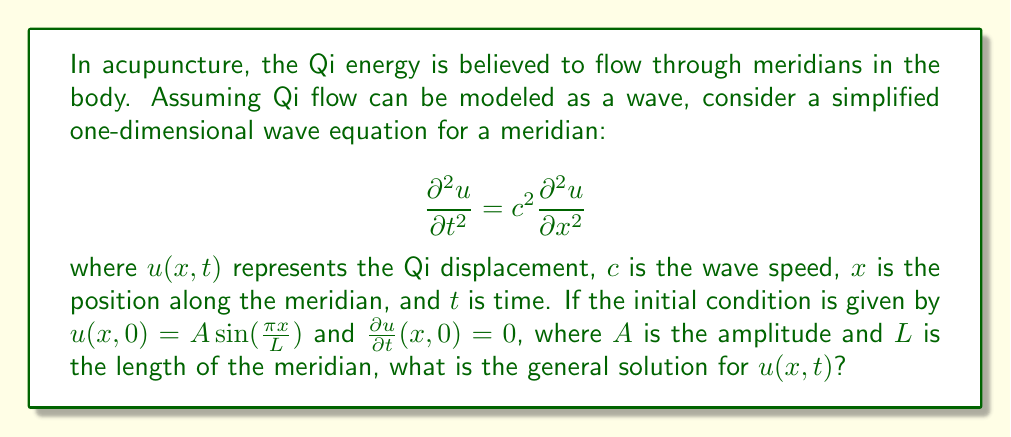Solve this math problem. To solve this wave equation with the given initial conditions, we'll follow these steps:

1) The general solution for a wave equation with these initial conditions takes the form:

   $$u(x,t) = f(x-ct) + g(x+ct)$$

2) Given the initial condition $u(x,0) = A \sin(\frac{\pi x}{L})$, we can deduce:

   $$f(x) + g(x) = A \sin(\frac{\pi x}{L})$$

3) The second initial condition $\frac{\partial u}{\partial t}(x,0) = 0$ implies:

   $$-cf'(x) + cg'(x) = 0$$
   $$f'(x) = g'(x)$$

4) Integrating this, we get:

   $$f(x) = g(x) + C$$

   where $C$ is a constant.

5) Substituting this into the equation from step 2:

   $$2g(x) + C = A \sin(\frac{\pi x}{L})$$
   $$g(x) = \frac{A}{2} \sin(\frac{\pi x}{L}) - \frac{C}{2}$$

6) Similarly:

   $$f(x) = \frac{A}{2} \sin(\frac{\pi x}{L}) + \frac{C}{2}$$

7) The constant $C$ can be eliminated as it represents a constant displacement that doesn't affect the wave pattern. So, we can set $C = 0$.

8) Now, substituting back into the general solution:

   $$u(x,t) = \frac{A}{2} \sin(\frac{\pi (x-ct)}{L}) + \frac{A}{2} \sin(\frac{\pi (x+ct)}{L})$$

9) Using the trigonometric identity for the sum of sines, this can be simplified to:

   $$u(x,t) = A \sin(\frac{\pi x}{L}) \cos(\frac{\pi ct}{L})$$

This is the general solution for the given wave equation and initial conditions.
Answer: $$u(x,t) = A \sin(\frac{\pi x}{L}) \cos(\frac{\pi ct}{L})$$ 